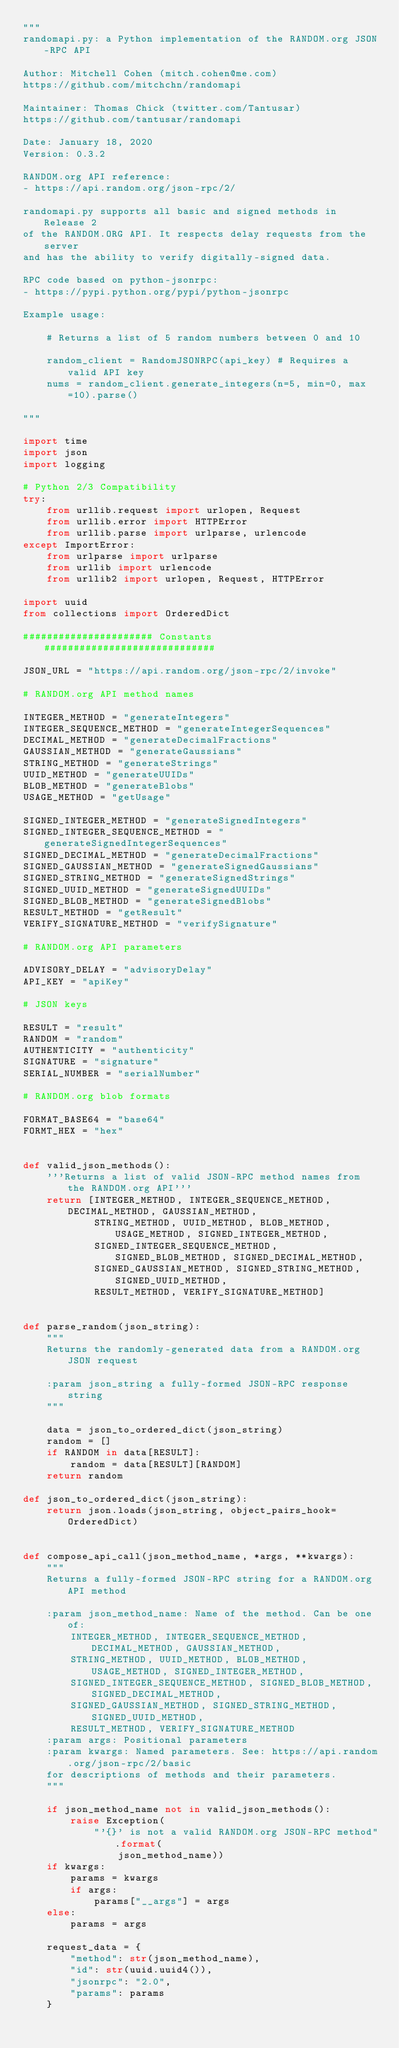<code> <loc_0><loc_0><loc_500><loc_500><_Python_>"""
randomapi.py: a Python implementation of the RANDOM.org JSON-RPC API

Author: Mitchell Cohen (mitch.cohen@me.com)
https://github.com/mitchchn/randomapi

Maintainer: Thomas Chick (twitter.com/Tantusar)
https://github.com/tantusar/randomapi

Date: January 18, 2020
Version: 0.3.2

RANDOM.org API reference:
- https://api.random.org/json-rpc/2/

randomapi.py supports all basic and signed methods in Release 2
of the RANDOM.ORG API. It respects delay requests from the server
and has the ability to verify digitally-signed data.

RPC code based on python-jsonrpc:
- https://pypi.python.org/pypi/python-jsonrpc

Example usage:

    # Returns a list of 5 random numbers between 0 and 10

    random_client = RandomJSONRPC(api_key) # Requires a valid API key
    nums = random_client.generate_integers(n=5, min=0, max=10).parse()

"""

import time
import json
import logging

# Python 2/3 Compatibility
try:
    from urllib.request import urlopen, Request
    from urllib.error import HTTPError
    from urllib.parse import urlparse, urlencode
except ImportError:
    from urlparse import urlparse
    from urllib import urlencode
    from urllib2 import urlopen, Request, HTTPError

import uuid
from collections import OrderedDict

###################### Constants #############################

JSON_URL = "https://api.random.org/json-rpc/2/invoke"

# RANDOM.org API method names

INTEGER_METHOD = "generateIntegers"
INTEGER_SEQUENCE_METHOD = "generateIntegerSequences"
DECIMAL_METHOD = "generateDecimalFractions"
GAUSSIAN_METHOD = "generateGaussians"
STRING_METHOD = "generateStrings"
UUID_METHOD = "generateUUIDs"
BLOB_METHOD = "generateBlobs"
USAGE_METHOD = "getUsage"

SIGNED_INTEGER_METHOD = "generateSignedIntegers"
SIGNED_INTEGER_SEQUENCE_METHOD = "generateSignedIntegerSequences"
SIGNED_DECIMAL_METHOD = "generateDecimalFractions"
SIGNED_GAUSSIAN_METHOD = "generateSignedGaussians"
SIGNED_STRING_METHOD = "generateSignedStrings"
SIGNED_UUID_METHOD = "generateSignedUUIDs"
SIGNED_BLOB_METHOD = "generateSignedBlobs"
RESULT_METHOD = "getResult"
VERIFY_SIGNATURE_METHOD = "verifySignature"

# RANDOM.org API parameters

ADVISORY_DELAY = "advisoryDelay"
API_KEY = "apiKey"

# JSON keys

RESULT = "result"
RANDOM = "random"
AUTHENTICITY = "authenticity"
SIGNATURE = "signature"
SERIAL_NUMBER = "serialNumber"

# RANDOM.org blob formats

FORMAT_BASE64 = "base64"
FORMT_HEX = "hex"


def valid_json_methods():
    '''Returns a list of valid JSON-RPC method names from the RANDOM.org API'''
    return [INTEGER_METHOD, INTEGER_SEQUENCE_METHOD, DECIMAL_METHOD, GAUSSIAN_METHOD,
            STRING_METHOD, UUID_METHOD, BLOB_METHOD, USAGE_METHOD, SIGNED_INTEGER_METHOD,
            SIGNED_INTEGER_SEQUENCE_METHOD, SIGNED_BLOB_METHOD, SIGNED_DECIMAL_METHOD,
            SIGNED_GAUSSIAN_METHOD, SIGNED_STRING_METHOD, SIGNED_UUID_METHOD,
            RESULT_METHOD, VERIFY_SIGNATURE_METHOD]


def parse_random(json_string):
    """
    Returns the randomly-generated data from a RANDOM.org JSON request

    :param json_string a fully-formed JSON-RPC response string
    """

    data = json_to_ordered_dict(json_string)
    random = []
    if RANDOM in data[RESULT]:
        random = data[RESULT][RANDOM]
    return random

def json_to_ordered_dict(json_string):
    return json.loads(json_string, object_pairs_hook=OrderedDict)


def compose_api_call(json_method_name, *args, **kwargs):
    """
    Returns a fully-formed JSON-RPC string for a RANDOM.org API method

    :param json_method_name: Name of the method. Can be one of:
        INTEGER_METHOD, INTEGER_SEQUENCE_METHOD, DECIMAL_METHOD, GAUSSIAN_METHOD,
        STRING_METHOD, UUID_METHOD, BLOB_METHOD, USAGE_METHOD, SIGNED_INTEGER_METHOD,
        SIGNED_INTEGER_SEQUENCE_METHOD, SIGNED_BLOB_METHOD, SIGNED_DECIMAL_METHOD,
        SIGNED_GAUSSIAN_METHOD, SIGNED_STRING_METHOD, SIGNED_UUID_METHOD,
        RESULT_METHOD, VERIFY_SIGNATURE_METHOD
    :param args: Positional parameters
    :param kwargs: Named parameters. See: https://api.random.org/json-rpc/2/basic
    for descriptions of methods and their parameters.
    """

    if json_method_name not in valid_json_methods():
        raise Exception(
            "'{}' is not a valid RANDOM.org JSON-RPC method".format(
                json_method_name))
    if kwargs:
        params = kwargs
        if args:
            params["__args"] = args
    else:
        params = args

    request_data = {
        "method": str(json_method_name),
        "id": str(uuid.uuid4()),
        "jsonrpc": "2.0",
        "params": params
    }</code> 